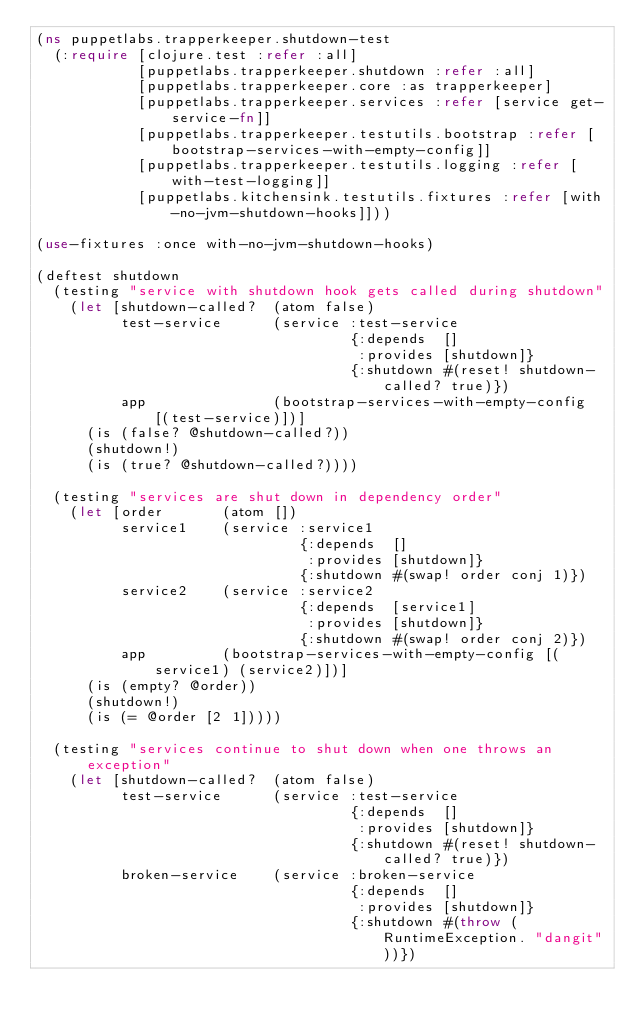Convert code to text. <code><loc_0><loc_0><loc_500><loc_500><_Clojure_>(ns puppetlabs.trapperkeeper.shutdown-test
  (:require [clojure.test :refer :all]
            [puppetlabs.trapperkeeper.shutdown :refer :all]
            [puppetlabs.trapperkeeper.core :as trapperkeeper]
            [puppetlabs.trapperkeeper.services :refer [service get-service-fn]]
            [puppetlabs.trapperkeeper.testutils.bootstrap :refer [bootstrap-services-with-empty-config]]
            [puppetlabs.trapperkeeper.testutils.logging :refer [with-test-logging]]
            [puppetlabs.kitchensink.testutils.fixtures :refer [with-no-jvm-shutdown-hooks]]))

(use-fixtures :once with-no-jvm-shutdown-hooks)

(deftest shutdown
  (testing "service with shutdown hook gets called during shutdown"
    (let [shutdown-called?  (atom false)
          test-service      (service :test-service
                                     {:depends  []
                                      :provides [shutdown]}
                                     {:shutdown #(reset! shutdown-called? true)})
          app               (bootstrap-services-with-empty-config [(test-service)])]
      (is (false? @shutdown-called?))
      (shutdown!)
      (is (true? @shutdown-called?))))

  (testing "services are shut down in dependency order"
    (let [order       (atom [])
          service1    (service :service1
                               {:depends  []
                                :provides [shutdown]}
                               {:shutdown #(swap! order conj 1)})
          service2    (service :service2
                               {:depends  [service1]
                                :provides [shutdown]}
                               {:shutdown #(swap! order conj 2)})
          app         (bootstrap-services-with-empty-config [(service1) (service2)])]
      (is (empty? @order))
      (shutdown!)
      (is (= @order [2 1]))))

  (testing "services continue to shut down when one throws an exception"
    (let [shutdown-called?  (atom false)
          test-service      (service :test-service
                                     {:depends  []
                                      :provides [shutdown]}
                                     {:shutdown #(reset! shutdown-called? true)})
          broken-service    (service :broken-service
                                     {:depends  []
                                      :provides [shutdown]}
                                     {:shutdown #(throw (RuntimeException. "dangit"))})</code> 